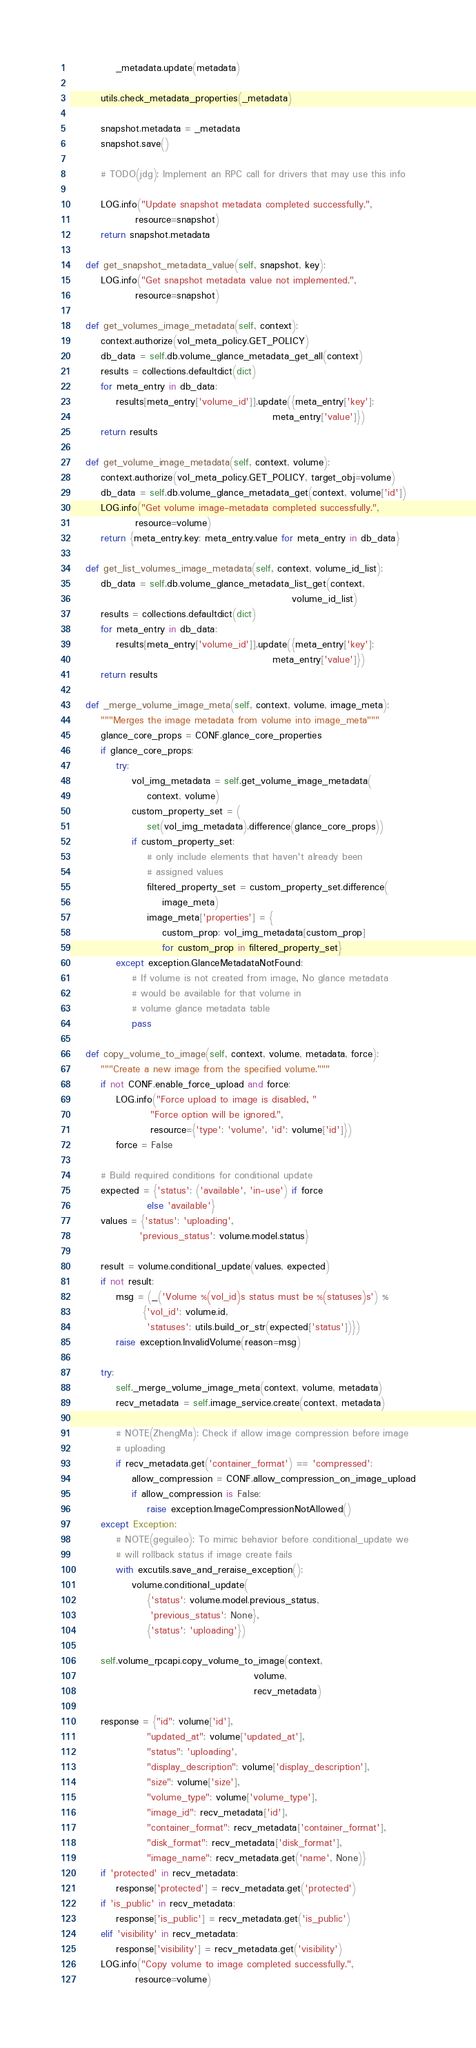<code> <loc_0><loc_0><loc_500><loc_500><_Python_>            _metadata.update(metadata)

        utils.check_metadata_properties(_metadata)

        snapshot.metadata = _metadata
        snapshot.save()

        # TODO(jdg): Implement an RPC call for drivers that may use this info

        LOG.info("Update snapshot metadata completed successfully.",
                 resource=snapshot)
        return snapshot.metadata

    def get_snapshot_metadata_value(self, snapshot, key):
        LOG.info("Get snapshot metadata value not implemented.",
                 resource=snapshot)

    def get_volumes_image_metadata(self, context):
        context.authorize(vol_meta_policy.GET_POLICY)
        db_data = self.db.volume_glance_metadata_get_all(context)
        results = collections.defaultdict(dict)
        for meta_entry in db_data:
            results[meta_entry['volume_id']].update({meta_entry['key']:
                                                     meta_entry['value']})
        return results

    def get_volume_image_metadata(self, context, volume):
        context.authorize(vol_meta_policy.GET_POLICY, target_obj=volume)
        db_data = self.db.volume_glance_metadata_get(context, volume['id'])
        LOG.info("Get volume image-metadata completed successfully.",
                 resource=volume)
        return {meta_entry.key: meta_entry.value for meta_entry in db_data}

    def get_list_volumes_image_metadata(self, context, volume_id_list):
        db_data = self.db.volume_glance_metadata_list_get(context,
                                                          volume_id_list)
        results = collections.defaultdict(dict)
        for meta_entry in db_data:
            results[meta_entry['volume_id']].update({meta_entry['key']:
                                                     meta_entry['value']})
        return results

    def _merge_volume_image_meta(self, context, volume, image_meta):
        """Merges the image metadata from volume into image_meta"""
        glance_core_props = CONF.glance_core_properties
        if glance_core_props:
            try:
                vol_img_metadata = self.get_volume_image_metadata(
                    context, volume)
                custom_property_set = (
                    set(vol_img_metadata).difference(glance_core_props))
                if custom_property_set:
                    # only include elements that haven't already been
                    # assigned values
                    filtered_property_set = custom_property_set.difference(
                        image_meta)
                    image_meta['properties'] = {
                        custom_prop: vol_img_metadata[custom_prop]
                        for custom_prop in filtered_property_set}
            except exception.GlanceMetadataNotFound:
                # If volume is not created from image, No glance metadata
                # would be available for that volume in
                # volume glance metadata table
                pass

    def copy_volume_to_image(self, context, volume, metadata, force):
        """Create a new image from the specified volume."""
        if not CONF.enable_force_upload and force:
            LOG.info("Force upload to image is disabled, "
                     "Force option will be ignored.",
                     resource={'type': 'volume', 'id': volume['id']})
            force = False

        # Build required conditions for conditional update
        expected = {'status': ('available', 'in-use') if force
                    else 'available'}
        values = {'status': 'uploading',
                  'previous_status': volume.model.status}

        result = volume.conditional_update(values, expected)
        if not result:
            msg = (_('Volume %(vol_id)s status must be %(statuses)s') %
                   {'vol_id': volume.id,
                    'statuses': utils.build_or_str(expected['status'])})
            raise exception.InvalidVolume(reason=msg)

        try:
            self._merge_volume_image_meta(context, volume, metadata)
            recv_metadata = self.image_service.create(context, metadata)

            # NOTE(ZhengMa): Check if allow image compression before image
            # uploading
            if recv_metadata.get('container_format') == 'compressed':
                allow_compression = CONF.allow_compression_on_image_upload
                if allow_compression is False:
                    raise exception.ImageCompressionNotAllowed()
        except Exception:
            # NOTE(geguileo): To mimic behavior before conditional_update we
            # will rollback status if image create fails
            with excutils.save_and_reraise_exception():
                volume.conditional_update(
                    {'status': volume.model.previous_status,
                     'previous_status': None},
                    {'status': 'uploading'})

        self.volume_rpcapi.copy_volume_to_image(context,
                                                volume,
                                                recv_metadata)

        response = {"id": volume['id'],
                    "updated_at": volume['updated_at'],
                    "status": 'uploading',
                    "display_description": volume['display_description'],
                    "size": volume['size'],
                    "volume_type": volume['volume_type'],
                    "image_id": recv_metadata['id'],
                    "container_format": recv_metadata['container_format'],
                    "disk_format": recv_metadata['disk_format'],
                    "image_name": recv_metadata.get('name', None)}
        if 'protected' in recv_metadata:
            response['protected'] = recv_metadata.get('protected')
        if 'is_public' in recv_metadata:
            response['is_public'] = recv_metadata.get('is_public')
        elif 'visibility' in recv_metadata:
            response['visibility'] = recv_metadata.get('visibility')
        LOG.info("Copy volume to image completed successfully.",
                 resource=volume)</code> 